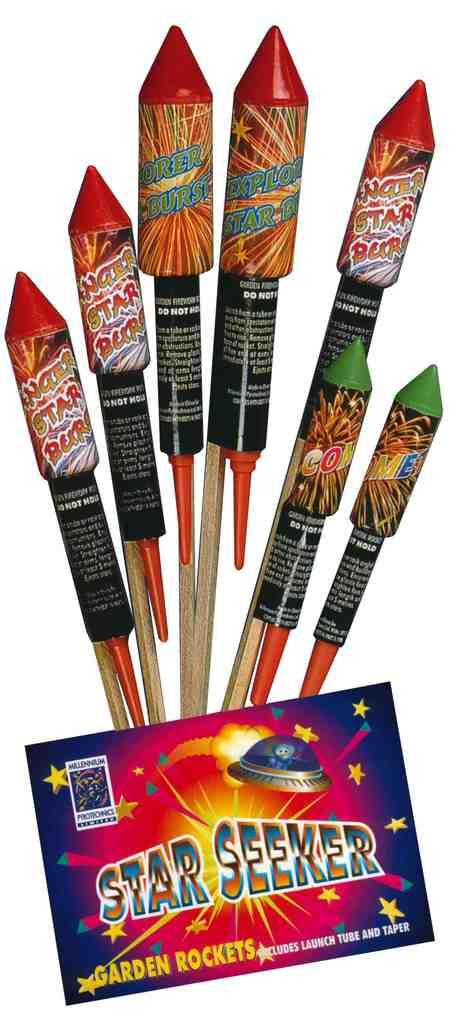What type of food can be seen in the image? There are crackers in the image. What other object is present in the image besides the crackers? There is a sticker in the image. What is written or depicted on the sticker? There is some text on the sticker. How many times does the cracker laugh or cry in the image? Crackers do not have the ability to laugh or cry, as they are inanimate objects. 